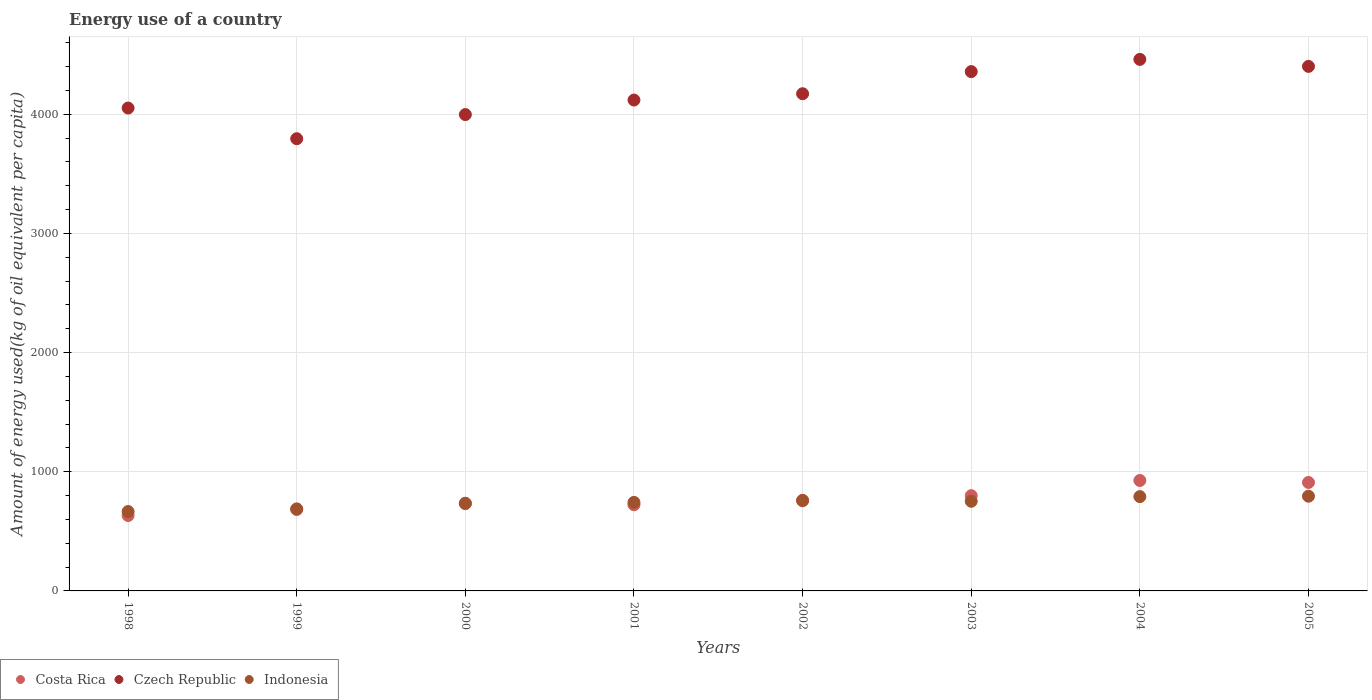Is the number of dotlines equal to the number of legend labels?
Your answer should be compact. Yes. What is the amount of energy used in in Indonesia in 2003?
Your answer should be very brief. 752.11. Across all years, what is the maximum amount of energy used in in Czech Republic?
Ensure brevity in your answer.  4459.63. Across all years, what is the minimum amount of energy used in in Indonesia?
Your answer should be compact. 666.13. In which year was the amount of energy used in in Costa Rica minimum?
Your response must be concise. 1998. What is the total amount of energy used in in Czech Republic in the graph?
Your answer should be very brief. 3.33e+04. What is the difference between the amount of energy used in in Czech Republic in 2001 and that in 2002?
Offer a terse response. -52.82. What is the difference between the amount of energy used in in Czech Republic in 2002 and the amount of energy used in in Indonesia in 1999?
Give a very brief answer. 3483.16. What is the average amount of energy used in in Czech Republic per year?
Offer a very short reply. 4168.68. In the year 2004, what is the difference between the amount of energy used in in Czech Republic and amount of energy used in in Indonesia?
Give a very brief answer. 3668.44. What is the ratio of the amount of energy used in in Indonesia in 1999 to that in 2003?
Give a very brief answer. 0.91. Is the difference between the amount of energy used in in Czech Republic in 1998 and 1999 greater than the difference between the amount of energy used in in Indonesia in 1998 and 1999?
Your answer should be compact. Yes. What is the difference between the highest and the second highest amount of energy used in in Czech Republic?
Provide a succinct answer. 58.75. What is the difference between the highest and the lowest amount of energy used in in Czech Republic?
Your answer should be very brief. 665.51. Does the amount of energy used in in Costa Rica monotonically increase over the years?
Offer a very short reply. No. How many dotlines are there?
Your answer should be very brief. 3. What is the difference between two consecutive major ticks on the Y-axis?
Your answer should be very brief. 1000. Are the values on the major ticks of Y-axis written in scientific E-notation?
Give a very brief answer. No. How many legend labels are there?
Offer a terse response. 3. What is the title of the graph?
Offer a very short reply. Energy use of a country. What is the label or title of the X-axis?
Offer a very short reply. Years. What is the label or title of the Y-axis?
Provide a succinct answer. Amount of energy used(kg of oil equivalent per capita). What is the Amount of energy used(kg of oil equivalent per capita) of Costa Rica in 1998?
Keep it short and to the point. 632.76. What is the Amount of energy used(kg of oil equivalent per capita) in Czech Republic in 1998?
Ensure brevity in your answer.  4051.41. What is the Amount of energy used(kg of oil equivalent per capita) in Indonesia in 1998?
Make the answer very short. 666.13. What is the Amount of energy used(kg of oil equivalent per capita) of Costa Rica in 1999?
Offer a terse response. 683.04. What is the Amount of energy used(kg of oil equivalent per capita) of Czech Republic in 1999?
Keep it short and to the point. 3794.11. What is the Amount of energy used(kg of oil equivalent per capita) in Indonesia in 1999?
Provide a short and direct response. 688.15. What is the Amount of energy used(kg of oil equivalent per capita) in Costa Rica in 2000?
Provide a short and direct response. 732.04. What is the Amount of energy used(kg of oil equivalent per capita) of Czech Republic in 2000?
Your answer should be very brief. 3996.58. What is the Amount of energy used(kg of oil equivalent per capita) in Indonesia in 2000?
Your answer should be very brief. 735.7. What is the Amount of energy used(kg of oil equivalent per capita) in Costa Rica in 2001?
Your response must be concise. 722.73. What is the Amount of energy used(kg of oil equivalent per capita) of Czech Republic in 2001?
Your answer should be very brief. 4118.49. What is the Amount of energy used(kg of oil equivalent per capita) in Indonesia in 2001?
Your response must be concise. 742.81. What is the Amount of energy used(kg of oil equivalent per capita) in Costa Rica in 2002?
Your response must be concise. 756.4. What is the Amount of energy used(kg of oil equivalent per capita) of Czech Republic in 2002?
Give a very brief answer. 4171.31. What is the Amount of energy used(kg of oil equivalent per capita) in Indonesia in 2002?
Offer a terse response. 760.07. What is the Amount of energy used(kg of oil equivalent per capita) in Costa Rica in 2003?
Offer a terse response. 799.16. What is the Amount of energy used(kg of oil equivalent per capita) of Czech Republic in 2003?
Your answer should be compact. 4357.05. What is the Amount of energy used(kg of oil equivalent per capita) of Indonesia in 2003?
Give a very brief answer. 752.11. What is the Amount of energy used(kg of oil equivalent per capita) in Costa Rica in 2004?
Make the answer very short. 926.63. What is the Amount of energy used(kg of oil equivalent per capita) of Czech Republic in 2004?
Keep it short and to the point. 4459.63. What is the Amount of energy used(kg of oil equivalent per capita) of Indonesia in 2004?
Your response must be concise. 791.19. What is the Amount of energy used(kg of oil equivalent per capita) of Costa Rica in 2005?
Provide a short and direct response. 909.82. What is the Amount of energy used(kg of oil equivalent per capita) of Czech Republic in 2005?
Keep it short and to the point. 4400.87. What is the Amount of energy used(kg of oil equivalent per capita) of Indonesia in 2005?
Ensure brevity in your answer.  794.62. Across all years, what is the maximum Amount of energy used(kg of oil equivalent per capita) in Costa Rica?
Your answer should be very brief. 926.63. Across all years, what is the maximum Amount of energy used(kg of oil equivalent per capita) of Czech Republic?
Offer a very short reply. 4459.63. Across all years, what is the maximum Amount of energy used(kg of oil equivalent per capita) in Indonesia?
Provide a short and direct response. 794.62. Across all years, what is the minimum Amount of energy used(kg of oil equivalent per capita) of Costa Rica?
Ensure brevity in your answer.  632.76. Across all years, what is the minimum Amount of energy used(kg of oil equivalent per capita) in Czech Republic?
Provide a short and direct response. 3794.11. Across all years, what is the minimum Amount of energy used(kg of oil equivalent per capita) of Indonesia?
Offer a terse response. 666.13. What is the total Amount of energy used(kg of oil equivalent per capita) of Costa Rica in the graph?
Provide a short and direct response. 6162.6. What is the total Amount of energy used(kg of oil equivalent per capita) of Czech Republic in the graph?
Give a very brief answer. 3.33e+04. What is the total Amount of energy used(kg of oil equivalent per capita) of Indonesia in the graph?
Provide a short and direct response. 5930.77. What is the difference between the Amount of energy used(kg of oil equivalent per capita) in Costa Rica in 1998 and that in 1999?
Keep it short and to the point. -50.28. What is the difference between the Amount of energy used(kg of oil equivalent per capita) in Czech Republic in 1998 and that in 1999?
Your answer should be compact. 257.3. What is the difference between the Amount of energy used(kg of oil equivalent per capita) in Indonesia in 1998 and that in 1999?
Provide a succinct answer. -22.01. What is the difference between the Amount of energy used(kg of oil equivalent per capita) of Costa Rica in 1998 and that in 2000?
Keep it short and to the point. -99.27. What is the difference between the Amount of energy used(kg of oil equivalent per capita) in Czech Republic in 1998 and that in 2000?
Your response must be concise. 54.84. What is the difference between the Amount of energy used(kg of oil equivalent per capita) in Indonesia in 1998 and that in 2000?
Offer a very short reply. -69.57. What is the difference between the Amount of energy used(kg of oil equivalent per capita) in Costa Rica in 1998 and that in 2001?
Your answer should be compact. -89.97. What is the difference between the Amount of energy used(kg of oil equivalent per capita) of Czech Republic in 1998 and that in 2001?
Provide a short and direct response. -67.08. What is the difference between the Amount of energy used(kg of oil equivalent per capita) in Indonesia in 1998 and that in 2001?
Make the answer very short. -76.67. What is the difference between the Amount of energy used(kg of oil equivalent per capita) of Costa Rica in 1998 and that in 2002?
Ensure brevity in your answer.  -123.63. What is the difference between the Amount of energy used(kg of oil equivalent per capita) in Czech Republic in 1998 and that in 2002?
Your response must be concise. -119.9. What is the difference between the Amount of energy used(kg of oil equivalent per capita) in Indonesia in 1998 and that in 2002?
Provide a succinct answer. -93.93. What is the difference between the Amount of energy used(kg of oil equivalent per capita) of Costa Rica in 1998 and that in 2003?
Ensure brevity in your answer.  -166.4. What is the difference between the Amount of energy used(kg of oil equivalent per capita) of Czech Republic in 1998 and that in 2003?
Make the answer very short. -305.64. What is the difference between the Amount of energy used(kg of oil equivalent per capita) of Indonesia in 1998 and that in 2003?
Provide a succinct answer. -85.97. What is the difference between the Amount of energy used(kg of oil equivalent per capita) of Costa Rica in 1998 and that in 2004?
Make the answer very short. -293.87. What is the difference between the Amount of energy used(kg of oil equivalent per capita) in Czech Republic in 1998 and that in 2004?
Ensure brevity in your answer.  -408.21. What is the difference between the Amount of energy used(kg of oil equivalent per capita) of Indonesia in 1998 and that in 2004?
Offer a very short reply. -125.06. What is the difference between the Amount of energy used(kg of oil equivalent per capita) in Costa Rica in 1998 and that in 2005?
Your answer should be very brief. -277.05. What is the difference between the Amount of energy used(kg of oil equivalent per capita) in Czech Republic in 1998 and that in 2005?
Make the answer very short. -349.46. What is the difference between the Amount of energy used(kg of oil equivalent per capita) in Indonesia in 1998 and that in 2005?
Offer a terse response. -128.49. What is the difference between the Amount of energy used(kg of oil equivalent per capita) in Costa Rica in 1999 and that in 2000?
Your response must be concise. -49. What is the difference between the Amount of energy used(kg of oil equivalent per capita) of Czech Republic in 1999 and that in 2000?
Ensure brevity in your answer.  -202.46. What is the difference between the Amount of energy used(kg of oil equivalent per capita) in Indonesia in 1999 and that in 2000?
Offer a terse response. -47.55. What is the difference between the Amount of energy used(kg of oil equivalent per capita) in Costa Rica in 1999 and that in 2001?
Offer a terse response. -39.69. What is the difference between the Amount of energy used(kg of oil equivalent per capita) in Czech Republic in 1999 and that in 2001?
Your response must be concise. -324.38. What is the difference between the Amount of energy used(kg of oil equivalent per capita) of Indonesia in 1999 and that in 2001?
Provide a succinct answer. -54.66. What is the difference between the Amount of energy used(kg of oil equivalent per capita) of Costa Rica in 1999 and that in 2002?
Provide a short and direct response. -73.35. What is the difference between the Amount of energy used(kg of oil equivalent per capita) in Czech Republic in 1999 and that in 2002?
Give a very brief answer. -377.2. What is the difference between the Amount of energy used(kg of oil equivalent per capita) of Indonesia in 1999 and that in 2002?
Provide a short and direct response. -71.92. What is the difference between the Amount of energy used(kg of oil equivalent per capita) in Costa Rica in 1999 and that in 2003?
Give a very brief answer. -116.12. What is the difference between the Amount of energy used(kg of oil equivalent per capita) in Czech Republic in 1999 and that in 2003?
Your answer should be very brief. -562.94. What is the difference between the Amount of energy used(kg of oil equivalent per capita) of Indonesia in 1999 and that in 2003?
Provide a succinct answer. -63.96. What is the difference between the Amount of energy used(kg of oil equivalent per capita) in Costa Rica in 1999 and that in 2004?
Keep it short and to the point. -243.59. What is the difference between the Amount of energy used(kg of oil equivalent per capita) of Czech Republic in 1999 and that in 2004?
Make the answer very short. -665.51. What is the difference between the Amount of energy used(kg of oil equivalent per capita) of Indonesia in 1999 and that in 2004?
Your response must be concise. -103.04. What is the difference between the Amount of energy used(kg of oil equivalent per capita) in Costa Rica in 1999 and that in 2005?
Offer a terse response. -226.78. What is the difference between the Amount of energy used(kg of oil equivalent per capita) in Czech Republic in 1999 and that in 2005?
Offer a very short reply. -606.76. What is the difference between the Amount of energy used(kg of oil equivalent per capita) of Indonesia in 1999 and that in 2005?
Keep it short and to the point. -106.48. What is the difference between the Amount of energy used(kg of oil equivalent per capita) in Costa Rica in 2000 and that in 2001?
Make the answer very short. 9.31. What is the difference between the Amount of energy used(kg of oil equivalent per capita) of Czech Republic in 2000 and that in 2001?
Your answer should be very brief. -121.92. What is the difference between the Amount of energy used(kg of oil equivalent per capita) of Indonesia in 2000 and that in 2001?
Give a very brief answer. -7.11. What is the difference between the Amount of energy used(kg of oil equivalent per capita) in Costa Rica in 2000 and that in 2002?
Offer a very short reply. -24.36. What is the difference between the Amount of energy used(kg of oil equivalent per capita) of Czech Republic in 2000 and that in 2002?
Your answer should be very brief. -174.73. What is the difference between the Amount of energy used(kg of oil equivalent per capita) of Indonesia in 2000 and that in 2002?
Provide a succinct answer. -24.37. What is the difference between the Amount of energy used(kg of oil equivalent per capita) in Costa Rica in 2000 and that in 2003?
Keep it short and to the point. -67.13. What is the difference between the Amount of energy used(kg of oil equivalent per capita) of Czech Republic in 2000 and that in 2003?
Provide a short and direct response. -360.47. What is the difference between the Amount of energy used(kg of oil equivalent per capita) in Indonesia in 2000 and that in 2003?
Ensure brevity in your answer.  -16.41. What is the difference between the Amount of energy used(kg of oil equivalent per capita) of Costa Rica in 2000 and that in 2004?
Offer a very short reply. -194.59. What is the difference between the Amount of energy used(kg of oil equivalent per capita) in Czech Republic in 2000 and that in 2004?
Ensure brevity in your answer.  -463.05. What is the difference between the Amount of energy used(kg of oil equivalent per capita) in Indonesia in 2000 and that in 2004?
Your answer should be very brief. -55.49. What is the difference between the Amount of energy used(kg of oil equivalent per capita) in Costa Rica in 2000 and that in 2005?
Your answer should be very brief. -177.78. What is the difference between the Amount of energy used(kg of oil equivalent per capita) in Czech Republic in 2000 and that in 2005?
Keep it short and to the point. -404.29. What is the difference between the Amount of energy used(kg of oil equivalent per capita) in Indonesia in 2000 and that in 2005?
Offer a terse response. -58.92. What is the difference between the Amount of energy used(kg of oil equivalent per capita) of Costa Rica in 2001 and that in 2002?
Provide a succinct answer. -33.66. What is the difference between the Amount of energy used(kg of oil equivalent per capita) of Czech Republic in 2001 and that in 2002?
Your response must be concise. -52.82. What is the difference between the Amount of energy used(kg of oil equivalent per capita) in Indonesia in 2001 and that in 2002?
Give a very brief answer. -17.26. What is the difference between the Amount of energy used(kg of oil equivalent per capita) of Costa Rica in 2001 and that in 2003?
Provide a short and direct response. -76.43. What is the difference between the Amount of energy used(kg of oil equivalent per capita) of Czech Republic in 2001 and that in 2003?
Make the answer very short. -238.56. What is the difference between the Amount of energy used(kg of oil equivalent per capita) of Indonesia in 2001 and that in 2003?
Make the answer very short. -9.3. What is the difference between the Amount of energy used(kg of oil equivalent per capita) of Costa Rica in 2001 and that in 2004?
Keep it short and to the point. -203.9. What is the difference between the Amount of energy used(kg of oil equivalent per capita) in Czech Republic in 2001 and that in 2004?
Make the answer very short. -341.13. What is the difference between the Amount of energy used(kg of oil equivalent per capita) of Indonesia in 2001 and that in 2004?
Your response must be concise. -48.38. What is the difference between the Amount of energy used(kg of oil equivalent per capita) of Costa Rica in 2001 and that in 2005?
Offer a very short reply. -187.09. What is the difference between the Amount of energy used(kg of oil equivalent per capita) of Czech Republic in 2001 and that in 2005?
Offer a very short reply. -282.38. What is the difference between the Amount of energy used(kg of oil equivalent per capita) of Indonesia in 2001 and that in 2005?
Keep it short and to the point. -51.82. What is the difference between the Amount of energy used(kg of oil equivalent per capita) in Costa Rica in 2002 and that in 2003?
Offer a very short reply. -42.77. What is the difference between the Amount of energy used(kg of oil equivalent per capita) in Czech Republic in 2002 and that in 2003?
Your answer should be compact. -185.74. What is the difference between the Amount of energy used(kg of oil equivalent per capita) in Indonesia in 2002 and that in 2003?
Provide a short and direct response. 7.96. What is the difference between the Amount of energy used(kg of oil equivalent per capita) of Costa Rica in 2002 and that in 2004?
Offer a very short reply. -170.23. What is the difference between the Amount of energy used(kg of oil equivalent per capita) in Czech Republic in 2002 and that in 2004?
Offer a very short reply. -288.32. What is the difference between the Amount of energy used(kg of oil equivalent per capita) in Indonesia in 2002 and that in 2004?
Your response must be concise. -31.12. What is the difference between the Amount of energy used(kg of oil equivalent per capita) in Costa Rica in 2002 and that in 2005?
Offer a very short reply. -153.42. What is the difference between the Amount of energy used(kg of oil equivalent per capita) in Czech Republic in 2002 and that in 2005?
Provide a succinct answer. -229.56. What is the difference between the Amount of energy used(kg of oil equivalent per capita) of Indonesia in 2002 and that in 2005?
Ensure brevity in your answer.  -34.56. What is the difference between the Amount of energy used(kg of oil equivalent per capita) in Costa Rica in 2003 and that in 2004?
Provide a succinct answer. -127.47. What is the difference between the Amount of energy used(kg of oil equivalent per capita) of Czech Republic in 2003 and that in 2004?
Ensure brevity in your answer.  -102.57. What is the difference between the Amount of energy used(kg of oil equivalent per capita) in Indonesia in 2003 and that in 2004?
Your response must be concise. -39.08. What is the difference between the Amount of energy used(kg of oil equivalent per capita) of Costa Rica in 2003 and that in 2005?
Provide a succinct answer. -110.66. What is the difference between the Amount of energy used(kg of oil equivalent per capita) of Czech Republic in 2003 and that in 2005?
Your answer should be very brief. -43.82. What is the difference between the Amount of energy used(kg of oil equivalent per capita) in Indonesia in 2003 and that in 2005?
Ensure brevity in your answer.  -42.52. What is the difference between the Amount of energy used(kg of oil equivalent per capita) of Costa Rica in 2004 and that in 2005?
Ensure brevity in your answer.  16.81. What is the difference between the Amount of energy used(kg of oil equivalent per capita) in Czech Republic in 2004 and that in 2005?
Ensure brevity in your answer.  58.75. What is the difference between the Amount of energy used(kg of oil equivalent per capita) in Indonesia in 2004 and that in 2005?
Provide a succinct answer. -3.44. What is the difference between the Amount of energy used(kg of oil equivalent per capita) of Costa Rica in 1998 and the Amount of energy used(kg of oil equivalent per capita) of Czech Republic in 1999?
Your answer should be compact. -3161.35. What is the difference between the Amount of energy used(kg of oil equivalent per capita) in Costa Rica in 1998 and the Amount of energy used(kg of oil equivalent per capita) in Indonesia in 1999?
Offer a terse response. -55.38. What is the difference between the Amount of energy used(kg of oil equivalent per capita) of Czech Republic in 1998 and the Amount of energy used(kg of oil equivalent per capita) of Indonesia in 1999?
Your response must be concise. 3363.27. What is the difference between the Amount of energy used(kg of oil equivalent per capita) of Costa Rica in 1998 and the Amount of energy used(kg of oil equivalent per capita) of Czech Republic in 2000?
Ensure brevity in your answer.  -3363.81. What is the difference between the Amount of energy used(kg of oil equivalent per capita) of Costa Rica in 1998 and the Amount of energy used(kg of oil equivalent per capita) of Indonesia in 2000?
Your response must be concise. -102.93. What is the difference between the Amount of energy used(kg of oil equivalent per capita) of Czech Republic in 1998 and the Amount of energy used(kg of oil equivalent per capita) of Indonesia in 2000?
Keep it short and to the point. 3315.71. What is the difference between the Amount of energy used(kg of oil equivalent per capita) in Costa Rica in 1998 and the Amount of energy used(kg of oil equivalent per capita) in Czech Republic in 2001?
Make the answer very short. -3485.73. What is the difference between the Amount of energy used(kg of oil equivalent per capita) of Costa Rica in 1998 and the Amount of energy used(kg of oil equivalent per capita) of Indonesia in 2001?
Keep it short and to the point. -110.04. What is the difference between the Amount of energy used(kg of oil equivalent per capita) of Czech Republic in 1998 and the Amount of energy used(kg of oil equivalent per capita) of Indonesia in 2001?
Offer a very short reply. 3308.61. What is the difference between the Amount of energy used(kg of oil equivalent per capita) in Costa Rica in 1998 and the Amount of energy used(kg of oil equivalent per capita) in Czech Republic in 2002?
Make the answer very short. -3538.54. What is the difference between the Amount of energy used(kg of oil equivalent per capita) in Costa Rica in 1998 and the Amount of energy used(kg of oil equivalent per capita) in Indonesia in 2002?
Your answer should be compact. -127.3. What is the difference between the Amount of energy used(kg of oil equivalent per capita) of Czech Republic in 1998 and the Amount of energy used(kg of oil equivalent per capita) of Indonesia in 2002?
Provide a succinct answer. 3291.35. What is the difference between the Amount of energy used(kg of oil equivalent per capita) of Costa Rica in 1998 and the Amount of energy used(kg of oil equivalent per capita) of Czech Republic in 2003?
Provide a short and direct response. -3724.29. What is the difference between the Amount of energy used(kg of oil equivalent per capita) in Costa Rica in 1998 and the Amount of energy used(kg of oil equivalent per capita) in Indonesia in 2003?
Your response must be concise. -119.34. What is the difference between the Amount of energy used(kg of oil equivalent per capita) of Czech Republic in 1998 and the Amount of energy used(kg of oil equivalent per capita) of Indonesia in 2003?
Provide a succinct answer. 3299.31. What is the difference between the Amount of energy used(kg of oil equivalent per capita) of Costa Rica in 1998 and the Amount of energy used(kg of oil equivalent per capita) of Czech Republic in 2004?
Make the answer very short. -3826.86. What is the difference between the Amount of energy used(kg of oil equivalent per capita) in Costa Rica in 1998 and the Amount of energy used(kg of oil equivalent per capita) in Indonesia in 2004?
Provide a succinct answer. -158.42. What is the difference between the Amount of energy used(kg of oil equivalent per capita) in Czech Republic in 1998 and the Amount of energy used(kg of oil equivalent per capita) in Indonesia in 2004?
Provide a succinct answer. 3260.22. What is the difference between the Amount of energy used(kg of oil equivalent per capita) in Costa Rica in 1998 and the Amount of energy used(kg of oil equivalent per capita) in Czech Republic in 2005?
Offer a very short reply. -3768.11. What is the difference between the Amount of energy used(kg of oil equivalent per capita) in Costa Rica in 1998 and the Amount of energy used(kg of oil equivalent per capita) in Indonesia in 2005?
Your answer should be compact. -161.86. What is the difference between the Amount of energy used(kg of oil equivalent per capita) in Czech Republic in 1998 and the Amount of energy used(kg of oil equivalent per capita) in Indonesia in 2005?
Offer a very short reply. 3256.79. What is the difference between the Amount of energy used(kg of oil equivalent per capita) in Costa Rica in 1999 and the Amount of energy used(kg of oil equivalent per capita) in Czech Republic in 2000?
Your answer should be very brief. -3313.53. What is the difference between the Amount of energy used(kg of oil equivalent per capita) of Costa Rica in 1999 and the Amount of energy used(kg of oil equivalent per capita) of Indonesia in 2000?
Provide a succinct answer. -52.66. What is the difference between the Amount of energy used(kg of oil equivalent per capita) in Czech Republic in 1999 and the Amount of energy used(kg of oil equivalent per capita) in Indonesia in 2000?
Provide a short and direct response. 3058.41. What is the difference between the Amount of energy used(kg of oil equivalent per capita) of Costa Rica in 1999 and the Amount of energy used(kg of oil equivalent per capita) of Czech Republic in 2001?
Ensure brevity in your answer.  -3435.45. What is the difference between the Amount of energy used(kg of oil equivalent per capita) of Costa Rica in 1999 and the Amount of energy used(kg of oil equivalent per capita) of Indonesia in 2001?
Your answer should be very brief. -59.76. What is the difference between the Amount of energy used(kg of oil equivalent per capita) of Czech Republic in 1999 and the Amount of energy used(kg of oil equivalent per capita) of Indonesia in 2001?
Your answer should be very brief. 3051.31. What is the difference between the Amount of energy used(kg of oil equivalent per capita) in Costa Rica in 1999 and the Amount of energy used(kg of oil equivalent per capita) in Czech Republic in 2002?
Keep it short and to the point. -3488.27. What is the difference between the Amount of energy used(kg of oil equivalent per capita) in Costa Rica in 1999 and the Amount of energy used(kg of oil equivalent per capita) in Indonesia in 2002?
Offer a terse response. -77.02. What is the difference between the Amount of energy used(kg of oil equivalent per capita) of Czech Republic in 1999 and the Amount of energy used(kg of oil equivalent per capita) of Indonesia in 2002?
Give a very brief answer. 3034.05. What is the difference between the Amount of energy used(kg of oil equivalent per capita) of Costa Rica in 1999 and the Amount of energy used(kg of oil equivalent per capita) of Czech Republic in 2003?
Provide a succinct answer. -3674.01. What is the difference between the Amount of energy used(kg of oil equivalent per capita) in Costa Rica in 1999 and the Amount of energy used(kg of oil equivalent per capita) in Indonesia in 2003?
Your answer should be compact. -69.06. What is the difference between the Amount of energy used(kg of oil equivalent per capita) of Czech Republic in 1999 and the Amount of energy used(kg of oil equivalent per capita) of Indonesia in 2003?
Give a very brief answer. 3042.01. What is the difference between the Amount of energy used(kg of oil equivalent per capita) of Costa Rica in 1999 and the Amount of energy used(kg of oil equivalent per capita) of Czech Republic in 2004?
Ensure brevity in your answer.  -3776.58. What is the difference between the Amount of energy used(kg of oil equivalent per capita) of Costa Rica in 1999 and the Amount of energy used(kg of oil equivalent per capita) of Indonesia in 2004?
Offer a very short reply. -108.15. What is the difference between the Amount of energy used(kg of oil equivalent per capita) in Czech Republic in 1999 and the Amount of energy used(kg of oil equivalent per capita) in Indonesia in 2004?
Your answer should be very brief. 3002.92. What is the difference between the Amount of energy used(kg of oil equivalent per capita) in Costa Rica in 1999 and the Amount of energy used(kg of oil equivalent per capita) in Czech Republic in 2005?
Ensure brevity in your answer.  -3717.83. What is the difference between the Amount of energy used(kg of oil equivalent per capita) in Costa Rica in 1999 and the Amount of energy used(kg of oil equivalent per capita) in Indonesia in 2005?
Your response must be concise. -111.58. What is the difference between the Amount of energy used(kg of oil equivalent per capita) of Czech Republic in 1999 and the Amount of energy used(kg of oil equivalent per capita) of Indonesia in 2005?
Your answer should be compact. 2999.49. What is the difference between the Amount of energy used(kg of oil equivalent per capita) in Costa Rica in 2000 and the Amount of energy used(kg of oil equivalent per capita) in Czech Republic in 2001?
Provide a succinct answer. -3386.45. What is the difference between the Amount of energy used(kg of oil equivalent per capita) of Costa Rica in 2000 and the Amount of energy used(kg of oil equivalent per capita) of Indonesia in 2001?
Your answer should be compact. -10.77. What is the difference between the Amount of energy used(kg of oil equivalent per capita) of Czech Republic in 2000 and the Amount of energy used(kg of oil equivalent per capita) of Indonesia in 2001?
Your answer should be compact. 3253.77. What is the difference between the Amount of energy used(kg of oil equivalent per capita) of Costa Rica in 2000 and the Amount of energy used(kg of oil equivalent per capita) of Czech Republic in 2002?
Your response must be concise. -3439.27. What is the difference between the Amount of energy used(kg of oil equivalent per capita) in Costa Rica in 2000 and the Amount of energy used(kg of oil equivalent per capita) in Indonesia in 2002?
Keep it short and to the point. -28.03. What is the difference between the Amount of energy used(kg of oil equivalent per capita) in Czech Republic in 2000 and the Amount of energy used(kg of oil equivalent per capita) in Indonesia in 2002?
Your answer should be very brief. 3236.51. What is the difference between the Amount of energy used(kg of oil equivalent per capita) in Costa Rica in 2000 and the Amount of energy used(kg of oil equivalent per capita) in Czech Republic in 2003?
Offer a terse response. -3625.01. What is the difference between the Amount of energy used(kg of oil equivalent per capita) of Costa Rica in 2000 and the Amount of energy used(kg of oil equivalent per capita) of Indonesia in 2003?
Offer a very short reply. -20.07. What is the difference between the Amount of energy used(kg of oil equivalent per capita) in Czech Republic in 2000 and the Amount of energy used(kg of oil equivalent per capita) in Indonesia in 2003?
Provide a short and direct response. 3244.47. What is the difference between the Amount of energy used(kg of oil equivalent per capita) in Costa Rica in 2000 and the Amount of energy used(kg of oil equivalent per capita) in Czech Republic in 2004?
Give a very brief answer. -3727.59. What is the difference between the Amount of energy used(kg of oil equivalent per capita) of Costa Rica in 2000 and the Amount of energy used(kg of oil equivalent per capita) of Indonesia in 2004?
Offer a very short reply. -59.15. What is the difference between the Amount of energy used(kg of oil equivalent per capita) in Czech Republic in 2000 and the Amount of energy used(kg of oil equivalent per capita) in Indonesia in 2004?
Provide a short and direct response. 3205.39. What is the difference between the Amount of energy used(kg of oil equivalent per capita) of Costa Rica in 2000 and the Amount of energy used(kg of oil equivalent per capita) of Czech Republic in 2005?
Provide a succinct answer. -3668.83. What is the difference between the Amount of energy used(kg of oil equivalent per capita) in Costa Rica in 2000 and the Amount of energy used(kg of oil equivalent per capita) in Indonesia in 2005?
Your answer should be very brief. -62.59. What is the difference between the Amount of energy used(kg of oil equivalent per capita) of Czech Republic in 2000 and the Amount of energy used(kg of oil equivalent per capita) of Indonesia in 2005?
Give a very brief answer. 3201.95. What is the difference between the Amount of energy used(kg of oil equivalent per capita) of Costa Rica in 2001 and the Amount of energy used(kg of oil equivalent per capita) of Czech Republic in 2002?
Provide a short and direct response. -3448.58. What is the difference between the Amount of energy used(kg of oil equivalent per capita) of Costa Rica in 2001 and the Amount of energy used(kg of oil equivalent per capita) of Indonesia in 2002?
Provide a succinct answer. -37.33. What is the difference between the Amount of energy used(kg of oil equivalent per capita) in Czech Republic in 2001 and the Amount of energy used(kg of oil equivalent per capita) in Indonesia in 2002?
Give a very brief answer. 3358.43. What is the difference between the Amount of energy used(kg of oil equivalent per capita) in Costa Rica in 2001 and the Amount of energy used(kg of oil equivalent per capita) in Czech Republic in 2003?
Ensure brevity in your answer.  -3634.32. What is the difference between the Amount of energy used(kg of oil equivalent per capita) in Costa Rica in 2001 and the Amount of energy used(kg of oil equivalent per capita) in Indonesia in 2003?
Your response must be concise. -29.37. What is the difference between the Amount of energy used(kg of oil equivalent per capita) of Czech Republic in 2001 and the Amount of energy used(kg of oil equivalent per capita) of Indonesia in 2003?
Your answer should be very brief. 3366.39. What is the difference between the Amount of energy used(kg of oil equivalent per capita) in Costa Rica in 2001 and the Amount of energy used(kg of oil equivalent per capita) in Czech Republic in 2004?
Provide a short and direct response. -3736.89. What is the difference between the Amount of energy used(kg of oil equivalent per capita) in Costa Rica in 2001 and the Amount of energy used(kg of oil equivalent per capita) in Indonesia in 2004?
Make the answer very short. -68.46. What is the difference between the Amount of energy used(kg of oil equivalent per capita) in Czech Republic in 2001 and the Amount of energy used(kg of oil equivalent per capita) in Indonesia in 2004?
Keep it short and to the point. 3327.3. What is the difference between the Amount of energy used(kg of oil equivalent per capita) in Costa Rica in 2001 and the Amount of energy used(kg of oil equivalent per capita) in Czech Republic in 2005?
Make the answer very short. -3678.14. What is the difference between the Amount of energy used(kg of oil equivalent per capita) of Costa Rica in 2001 and the Amount of energy used(kg of oil equivalent per capita) of Indonesia in 2005?
Provide a short and direct response. -71.89. What is the difference between the Amount of energy used(kg of oil equivalent per capita) of Czech Republic in 2001 and the Amount of energy used(kg of oil equivalent per capita) of Indonesia in 2005?
Ensure brevity in your answer.  3323.87. What is the difference between the Amount of energy used(kg of oil equivalent per capita) of Costa Rica in 2002 and the Amount of energy used(kg of oil equivalent per capita) of Czech Republic in 2003?
Keep it short and to the point. -3600.65. What is the difference between the Amount of energy used(kg of oil equivalent per capita) in Costa Rica in 2002 and the Amount of energy used(kg of oil equivalent per capita) in Indonesia in 2003?
Ensure brevity in your answer.  4.29. What is the difference between the Amount of energy used(kg of oil equivalent per capita) of Czech Republic in 2002 and the Amount of energy used(kg of oil equivalent per capita) of Indonesia in 2003?
Offer a very short reply. 3419.2. What is the difference between the Amount of energy used(kg of oil equivalent per capita) of Costa Rica in 2002 and the Amount of energy used(kg of oil equivalent per capita) of Czech Republic in 2004?
Your answer should be very brief. -3703.23. What is the difference between the Amount of energy used(kg of oil equivalent per capita) of Costa Rica in 2002 and the Amount of energy used(kg of oil equivalent per capita) of Indonesia in 2004?
Your response must be concise. -34.79. What is the difference between the Amount of energy used(kg of oil equivalent per capita) in Czech Republic in 2002 and the Amount of energy used(kg of oil equivalent per capita) in Indonesia in 2004?
Give a very brief answer. 3380.12. What is the difference between the Amount of energy used(kg of oil equivalent per capita) in Costa Rica in 2002 and the Amount of energy used(kg of oil equivalent per capita) in Czech Republic in 2005?
Your response must be concise. -3644.47. What is the difference between the Amount of energy used(kg of oil equivalent per capita) of Costa Rica in 2002 and the Amount of energy used(kg of oil equivalent per capita) of Indonesia in 2005?
Provide a short and direct response. -38.23. What is the difference between the Amount of energy used(kg of oil equivalent per capita) in Czech Republic in 2002 and the Amount of energy used(kg of oil equivalent per capita) in Indonesia in 2005?
Ensure brevity in your answer.  3376.68. What is the difference between the Amount of energy used(kg of oil equivalent per capita) of Costa Rica in 2003 and the Amount of energy used(kg of oil equivalent per capita) of Czech Republic in 2004?
Offer a very short reply. -3660.46. What is the difference between the Amount of energy used(kg of oil equivalent per capita) of Costa Rica in 2003 and the Amount of energy used(kg of oil equivalent per capita) of Indonesia in 2004?
Your answer should be compact. 7.98. What is the difference between the Amount of energy used(kg of oil equivalent per capita) of Czech Republic in 2003 and the Amount of energy used(kg of oil equivalent per capita) of Indonesia in 2004?
Your answer should be very brief. 3565.86. What is the difference between the Amount of energy used(kg of oil equivalent per capita) of Costa Rica in 2003 and the Amount of energy used(kg of oil equivalent per capita) of Czech Republic in 2005?
Provide a succinct answer. -3601.71. What is the difference between the Amount of energy used(kg of oil equivalent per capita) in Costa Rica in 2003 and the Amount of energy used(kg of oil equivalent per capita) in Indonesia in 2005?
Offer a terse response. 4.54. What is the difference between the Amount of energy used(kg of oil equivalent per capita) of Czech Republic in 2003 and the Amount of energy used(kg of oil equivalent per capita) of Indonesia in 2005?
Provide a succinct answer. 3562.43. What is the difference between the Amount of energy used(kg of oil equivalent per capita) in Costa Rica in 2004 and the Amount of energy used(kg of oil equivalent per capita) in Czech Republic in 2005?
Give a very brief answer. -3474.24. What is the difference between the Amount of energy used(kg of oil equivalent per capita) of Costa Rica in 2004 and the Amount of energy used(kg of oil equivalent per capita) of Indonesia in 2005?
Your answer should be compact. 132.01. What is the difference between the Amount of energy used(kg of oil equivalent per capita) in Czech Republic in 2004 and the Amount of energy used(kg of oil equivalent per capita) in Indonesia in 2005?
Ensure brevity in your answer.  3665. What is the average Amount of energy used(kg of oil equivalent per capita) in Costa Rica per year?
Keep it short and to the point. 770.32. What is the average Amount of energy used(kg of oil equivalent per capita) of Czech Republic per year?
Offer a very short reply. 4168.68. What is the average Amount of energy used(kg of oil equivalent per capita) in Indonesia per year?
Provide a short and direct response. 741.35. In the year 1998, what is the difference between the Amount of energy used(kg of oil equivalent per capita) in Costa Rica and Amount of energy used(kg of oil equivalent per capita) in Czech Republic?
Provide a short and direct response. -3418.65. In the year 1998, what is the difference between the Amount of energy used(kg of oil equivalent per capita) of Costa Rica and Amount of energy used(kg of oil equivalent per capita) of Indonesia?
Offer a terse response. -33.37. In the year 1998, what is the difference between the Amount of energy used(kg of oil equivalent per capita) of Czech Republic and Amount of energy used(kg of oil equivalent per capita) of Indonesia?
Ensure brevity in your answer.  3385.28. In the year 1999, what is the difference between the Amount of energy used(kg of oil equivalent per capita) in Costa Rica and Amount of energy used(kg of oil equivalent per capita) in Czech Republic?
Your response must be concise. -3111.07. In the year 1999, what is the difference between the Amount of energy used(kg of oil equivalent per capita) of Costa Rica and Amount of energy used(kg of oil equivalent per capita) of Indonesia?
Provide a succinct answer. -5.1. In the year 1999, what is the difference between the Amount of energy used(kg of oil equivalent per capita) of Czech Republic and Amount of energy used(kg of oil equivalent per capita) of Indonesia?
Provide a short and direct response. 3105.97. In the year 2000, what is the difference between the Amount of energy used(kg of oil equivalent per capita) in Costa Rica and Amount of energy used(kg of oil equivalent per capita) in Czech Republic?
Your answer should be compact. -3264.54. In the year 2000, what is the difference between the Amount of energy used(kg of oil equivalent per capita) of Costa Rica and Amount of energy used(kg of oil equivalent per capita) of Indonesia?
Your response must be concise. -3.66. In the year 2000, what is the difference between the Amount of energy used(kg of oil equivalent per capita) of Czech Republic and Amount of energy used(kg of oil equivalent per capita) of Indonesia?
Your answer should be compact. 3260.88. In the year 2001, what is the difference between the Amount of energy used(kg of oil equivalent per capita) in Costa Rica and Amount of energy used(kg of oil equivalent per capita) in Czech Republic?
Offer a terse response. -3395.76. In the year 2001, what is the difference between the Amount of energy used(kg of oil equivalent per capita) in Costa Rica and Amount of energy used(kg of oil equivalent per capita) in Indonesia?
Provide a short and direct response. -20.07. In the year 2001, what is the difference between the Amount of energy used(kg of oil equivalent per capita) of Czech Republic and Amount of energy used(kg of oil equivalent per capita) of Indonesia?
Offer a terse response. 3375.69. In the year 2002, what is the difference between the Amount of energy used(kg of oil equivalent per capita) in Costa Rica and Amount of energy used(kg of oil equivalent per capita) in Czech Republic?
Make the answer very short. -3414.91. In the year 2002, what is the difference between the Amount of energy used(kg of oil equivalent per capita) of Costa Rica and Amount of energy used(kg of oil equivalent per capita) of Indonesia?
Offer a terse response. -3.67. In the year 2002, what is the difference between the Amount of energy used(kg of oil equivalent per capita) in Czech Republic and Amount of energy used(kg of oil equivalent per capita) in Indonesia?
Give a very brief answer. 3411.24. In the year 2003, what is the difference between the Amount of energy used(kg of oil equivalent per capita) in Costa Rica and Amount of energy used(kg of oil equivalent per capita) in Czech Republic?
Your response must be concise. -3557.89. In the year 2003, what is the difference between the Amount of energy used(kg of oil equivalent per capita) in Costa Rica and Amount of energy used(kg of oil equivalent per capita) in Indonesia?
Ensure brevity in your answer.  47.06. In the year 2003, what is the difference between the Amount of energy used(kg of oil equivalent per capita) in Czech Republic and Amount of energy used(kg of oil equivalent per capita) in Indonesia?
Provide a short and direct response. 3604.94. In the year 2004, what is the difference between the Amount of energy used(kg of oil equivalent per capita) of Costa Rica and Amount of energy used(kg of oil equivalent per capita) of Czech Republic?
Provide a succinct answer. -3532.99. In the year 2004, what is the difference between the Amount of energy used(kg of oil equivalent per capita) in Costa Rica and Amount of energy used(kg of oil equivalent per capita) in Indonesia?
Your answer should be compact. 135.44. In the year 2004, what is the difference between the Amount of energy used(kg of oil equivalent per capita) in Czech Republic and Amount of energy used(kg of oil equivalent per capita) in Indonesia?
Your answer should be compact. 3668.44. In the year 2005, what is the difference between the Amount of energy used(kg of oil equivalent per capita) of Costa Rica and Amount of energy used(kg of oil equivalent per capita) of Czech Republic?
Keep it short and to the point. -3491.05. In the year 2005, what is the difference between the Amount of energy used(kg of oil equivalent per capita) in Costa Rica and Amount of energy used(kg of oil equivalent per capita) in Indonesia?
Provide a succinct answer. 115.2. In the year 2005, what is the difference between the Amount of energy used(kg of oil equivalent per capita) of Czech Republic and Amount of energy used(kg of oil equivalent per capita) of Indonesia?
Make the answer very short. 3606.25. What is the ratio of the Amount of energy used(kg of oil equivalent per capita) in Costa Rica in 1998 to that in 1999?
Your response must be concise. 0.93. What is the ratio of the Amount of energy used(kg of oil equivalent per capita) of Czech Republic in 1998 to that in 1999?
Provide a short and direct response. 1.07. What is the ratio of the Amount of energy used(kg of oil equivalent per capita) in Costa Rica in 1998 to that in 2000?
Make the answer very short. 0.86. What is the ratio of the Amount of energy used(kg of oil equivalent per capita) in Czech Republic in 1998 to that in 2000?
Provide a short and direct response. 1.01. What is the ratio of the Amount of energy used(kg of oil equivalent per capita) of Indonesia in 1998 to that in 2000?
Provide a succinct answer. 0.91. What is the ratio of the Amount of energy used(kg of oil equivalent per capita) of Costa Rica in 1998 to that in 2001?
Provide a succinct answer. 0.88. What is the ratio of the Amount of energy used(kg of oil equivalent per capita) of Czech Republic in 1998 to that in 2001?
Provide a short and direct response. 0.98. What is the ratio of the Amount of energy used(kg of oil equivalent per capita) of Indonesia in 1998 to that in 2001?
Keep it short and to the point. 0.9. What is the ratio of the Amount of energy used(kg of oil equivalent per capita) in Costa Rica in 1998 to that in 2002?
Give a very brief answer. 0.84. What is the ratio of the Amount of energy used(kg of oil equivalent per capita) in Czech Republic in 1998 to that in 2002?
Your answer should be compact. 0.97. What is the ratio of the Amount of energy used(kg of oil equivalent per capita) of Indonesia in 1998 to that in 2002?
Your answer should be very brief. 0.88. What is the ratio of the Amount of energy used(kg of oil equivalent per capita) in Costa Rica in 1998 to that in 2003?
Ensure brevity in your answer.  0.79. What is the ratio of the Amount of energy used(kg of oil equivalent per capita) of Czech Republic in 1998 to that in 2003?
Keep it short and to the point. 0.93. What is the ratio of the Amount of energy used(kg of oil equivalent per capita) of Indonesia in 1998 to that in 2003?
Provide a short and direct response. 0.89. What is the ratio of the Amount of energy used(kg of oil equivalent per capita) in Costa Rica in 1998 to that in 2004?
Your answer should be compact. 0.68. What is the ratio of the Amount of energy used(kg of oil equivalent per capita) of Czech Republic in 1998 to that in 2004?
Your answer should be compact. 0.91. What is the ratio of the Amount of energy used(kg of oil equivalent per capita) in Indonesia in 1998 to that in 2004?
Offer a terse response. 0.84. What is the ratio of the Amount of energy used(kg of oil equivalent per capita) in Costa Rica in 1998 to that in 2005?
Provide a short and direct response. 0.7. What is the ratio of the Amount of energy used(kg of oil equivalent per capita) in Czech Republic in 1998 to that in 2005?
Give a very brief answer. 0.92. What is the ratio of the Amount of energy used(kg of oil equivalent per capita) of Indonesia in 1998 to that in 2005?
Your response must be concise. 0.84. What is the ratio of the Amount of energy used(kg of oil equivalent per capita) in Costa Rica in 1999 to that in 2000?
Give a very brief answer. 0.93. What is the ratio of the Amount of energy used(kg of oil equivalent per capita) of Czech Republic in 1999 to that in 2000?
Offer a very short reply. 0.95. What is the ratio of the Amount of energy used(kg of oil equivalent per capita) of Indonesia in 1999 to that in 2000?
Give a very brief answer. 0.94. What is the ratio of the Amount of energy used(kg of oil equivalent per capita) of Costa Rica in 1999 to that in 2001?
Make the answer very short. 0.95. What is the ratio of the Amount of energy used(kg of oil equivalent per capita) in Czech Republic in 1999 to that in 2001?
Your response must be concise. 0.92. What is the ratio of the Amount of energy used(kg of oil equivalent per capita) in Indonesia in 1999 to that in 2001?
Your answer should be very brief. 0.93. What is the ratio of the Amount of energy used(kg of oil equivalent per capita) in Costa Rica in 1999 to that in 2002?
Offer a terse response. 0.9. What is the ratio of the Amount of energy used(kg of oil equivalent per capita) of Czech Republic in 1999 to that in 2002?
Your response must be concise. 0.91. What is the ratio of the Amount of energy used(kg of oil equivalent per capita) in Indonesia in 1999 to that in 2002?
Your response must be concise. 0.91. What is the ratio of the Amount of energy used(kg of oil equivalent per capita) in Costa Rica in 1999 to that in 2003?
Provide a succinct answer. 0.85. What is the ratio of the Amount of energy used(kg of oil equivalent per capita) of Czech Republic in 1999 to that in 2003?
Provide a short and direct response. 0.87. What is the ratio of the Amount of energy used(kg of oil equivalent per capita) of Indonesia in 1999 to that in 2003?
Give a very brief answer. 0.92. What is the ratio of the Amount of energy used(kg of oil equivalent per capita) of Costa Rica in 1999 to that in 2004?
Your answer should be very brief. 0.74. What is the ratio of the Amount of energy used(kg of oil equivalent per capita) in Czech Republic in 1999 to that in 2004?
Offer a terse response. 0.85. What is the ratio of the Amount of energy used(kg of oil equivalent per capita) in Indonesia in 1999 to that in 2004?
Keep it short and to the point. 0.87. What is the ratio of the Amount of energy used(kg of oil equivalent per capita) in Costa Rica in 1999 to that in 2005?
Offer a very short reply. 0.75. What is the ratio of the Amount of energy used(kg of oil equivalent per capita) of Czech Republic in 1999 to that in 2005?
Your response must be concise. 0.86. What is the ratio of the Amount of energy used(kg of oil equivalent per capita) of Indonesia in 1999 to that in 2005?
Ensure brevity in your answer.  0.87. What is the ratio of the Amount of energy used(kg of oil equivalent per capita) of Costa Rica in 2000 to that in 2001?
Your answer should be compact. 1.01. What is the ratio of the Amount of energy used(kg of oil equivalent per capita) of Czech Republic in 2000 to that in 2001?
Ensure brevity in your answer.  0.97. What is the ratio of the Amount of energy used(kg of oil equivalent per capita) in Costa Rica in 2000 to that in 2002?
Offer a terse response. 0.97. What is the ratio of the Amount of energy used(kg of oil equivalent per capita) of Czech Republic in 2000 to that in 2002?
Make the answer very short. 0.96. What is the ratio of the Amount of energy used(kg of oil equivalent per capita) in Indonesia in 2000 to that in 2002?
Offer a terse response. 0.97. What is the ratio of the Amount of energy used(kg of oil equivalent per capita) in Costa Rica in 2000 to that in 2003?
Your response must be concise. 0.92. What is the ratio of the Amount of energy used(kg of oil equivalent per capita) in Czech Republic in 2000 to that in 2003?
Provide a succinct answer. 0.92. What is the ratio of the Amount of energy used(kg of oil equivalent per capita) in Indonesia in 2000 to that in 2003?
Offer a very short reply. 0.98. What is the ratio of the Amount of energy used(kg of oil equivalent per capita) of Costa Rica in 2000 to that in 2004?
Ensure brevity in your answer.  0.79. What is the ratio of the Amount of energy used(kg of oil equivalent per capita) of Czech Republic in 2000 to that in 2004?
Keep it short and to the point. 0.9. What is the ratio of the Amount of energy used(kg of oil equivalent per capita) of Indonesia in 2000 to that in 2004?
Your answer should be very brief. 0.93. What is the ratio of the Amount of energy used(kg of oil equivalent per capita) in Costa Rica in 2000 to that in 2005?
Your response must be concise. 0.8. What is the ratio of the Amount of energy used(kg of oil equivalent per capita) in Czech Republic in 2000 to that in 2005?
Your answer should be compact. 0.91. What is the ratio of the Amount of energy used(kg of oil equivalent per capita) of Indonesia in 2000 to that in 2005?
Give a very brief answer. 0.93. What is the ratio of the Amount of energy used(kg of oil equivalent per capita) in Costa Rica in 2001 to that in 2002?
Offer a terse response. 0.96. What is the ratio of the Amount of energy used(kg of oil equivalent per capita) in Czech Republic in 2001 to that in 2002?
Provide a short and direct response. 0.99. What is the ratio of the Amount of energy used(kg of oil equivalent per capita) of Indonesia in 2001 to that in 2002?
Make the answer very short. 0.98. What is the ratio of the Amount of energy used(kg of oil equivalent per capita) of Costa Rica in 2001 to that in 2003?
Keep it short and to the point. 0.9. What is the ratio of the Amount of energy used(kg of oil equivalent per capita) of Czech Republic in 2001 to that in 2003?
Your answer should be compact. 0.95. What is the ratio of the Amount of energy used(kg of oil equivalent per capita) of Indonesia in 2001 to that in 2003?
Provide a short and direct response. 0.99. What is the ratio of the Amount of energy used(kg of oil equivalent per capita) in Costa Rica in 2001 to that in 2004?
Provide a short and direct response. 0.78. What is the ratio of the Amount of energy used(kg of oil equivalent per capita) of Czech Republic in 2001 to that in 2004?
Keep it short and to the point. 0.92. What is the ratio of the Amount of energy used(kg of oil equivalent per capita) of Indonesia in 2001 to that in 2004?
Offer a terse response. 0.94. What is the ratio of the Amount of energy used(kg of oil equivalent per capita) of Costa Rica in 2001 to that in 2005?
Provide a short and direct response. 0.79. What is the ratio of the Amount of energy used(kg of oil equivalent per capita) in Czech Republic in 2001 to that in 2005?
Your answer should be very brief. 0.94. What is the ratio of the Amount of energy used(kg of oil equivalent per capita) of Indonesia in 2001 to that in 2005?
Give a very brief answer. 0.93. What is the ratio of the Amount of energy used(kg of oil equivalent per capita) of Costa Rica in 2002 to that in 2003?
Offer a very short reply. 0.95. What is the ratio of the Amount of energy used(kg of oil equivalent per capita) in Czech Republic in 2002 to that in 2003?
Provide a short and direct response. 0.96. What is the ratio of the Amount of energy used(kg of oil equivalent per capita) of Indonesia in 2002 to that in 2003?
Keep it short and to the point. 1.01. What is the ratio of the Amount of energy used(kg of oil equivalent per capita) in Costa Rica in 2002 to that in 2004?
Give a very brief answer. 0.82. What is the ratio of the Amount of energy used(kg of oil equivalent per capita) of Czech Republic in 2002 to that in 2004?
Offer a very short reply. 0.94. What is the ratio of the Amount of energy used(kg of oil equivalent per capita) of Indonesia in 2002 to that in 2004?
Give a very brief answer. 0.96. What is the ratio of the Amount of energy used(kg of oil equivalent per capita) of Costa Rica in 2002 to that in 2005?
Provide a short and direct response. 0.83. What is the ratio of the Amount of energy used(kg of oil equivalent per capita) in Czech Republic in 2002 to that in 2005?
Give a very brief answer. 0.95. What is the ratio of the Amount of energy used(kg of oil equivalent per capita) in Indonesia in 2002 to that in 2005?
Your answer should be very brief. 0.96. What is the ratio of the Amount of energy used(kg of oil equivalent per capita) of Costa Rica in 2003 to that in 2004?
Offer a terse response. 0.86. What is the ratio of the Amount of energy used(kg of oil equivalent per capita) of Indonesia in 2003 to that in 2004?
Make the answer very short. 0.95. What is the ratio of the Amount of energy used(kg of oil equivalent per capita) of Costa Rica in 2003 to that in 2005?
Your answer should be compact. 0.88. What is the ratio of the Amount of energy used(kg of oil equivalent per capita) of Czech Republic in 2003 to that in 2005?
Ensure brevity in your answer.  0.99. What is the ratio of the Amount of energy used(kg of oil equivalent per capita) in Indonesia in 2003 to that in 2005?
Offer a very short reply. 0.95. What is the ratio of the Amount of energy used(kg of oil equivalent per capita) in Costa Rica in 2004 to that in 2005?
Offer a terse response. 1.02. What is the ratio of the Amount of energy used(kg of oil equivalent per capita) in Czech Republic in 2004 to that in 2005?
Give a very brief answer. 1.01. What is the difference between the highest and the second highest Amount of energy used(kg of oil equivalent per capita) of Costa Rica?
Your answer should be compact. 16.81. What is the difference between the highest and the second highest Amount of energy used(kg of oil equivalent per capita) in Czech Republic?
Your response must be concise. 58.75. What is the difference between the highest and the second highest Amount of energy used(kg of oil equivalent per capita) in Indonesia?
Provide a succinct answer. 3.44. What is the difference between the highest and the lowest Amount of energy used(kg of oil equivalent per capita) in Costa Rica?
Offer a terse response. 293.87. What is the difference between the highest and the lowest Amount of energy used(kg of oil equivalent per capita) of Czech Republic?
Your response must be concise. 665.51. What is the difference between the highest and the lowest Amount of energy used(kg of oil equivalent per capita) of Indonesia?
Offer a terse response. 128.49. 